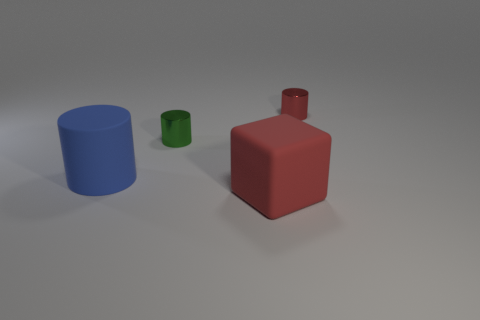What shape is the red thing that is the same size as the blue object?
Provide a short and direct response. Cube. There is a red object that is the same material as the large blue object; what is its size?
Offer a very short reply. Large. Do the tiny green shiny thing and the large blue rubber thing have the same shape?
Offer a terse response. Yes. There is a thing that is the same size as the rubber cylinder; what is its color?
Offer a terse response. Red. What size is the blue object that is the same shape as the small green object?
Your answer should be very brief. Large. What shape is the matte thing behind the block?
Ensure brevity in your answer.  Cylinder. There is a big blue rubber thing; is its shape the same as the red thing that is in front of the small green thing?
Ensure brevity in your answer.  No. Are there the same number of blue things on the left side of the blue cylinder and big objects that are on the right side of the block?
Keep it short and to the point. Yes. There is a tiny metallic thing that is the same color as the large matte block; what is its shape?
Your response must be concise. Cylinder. Is the color of the small object left of the red metal cylinder the same as the matte object to the right of the rubber cylinder?
Ensure brevity in your answer.  No. 